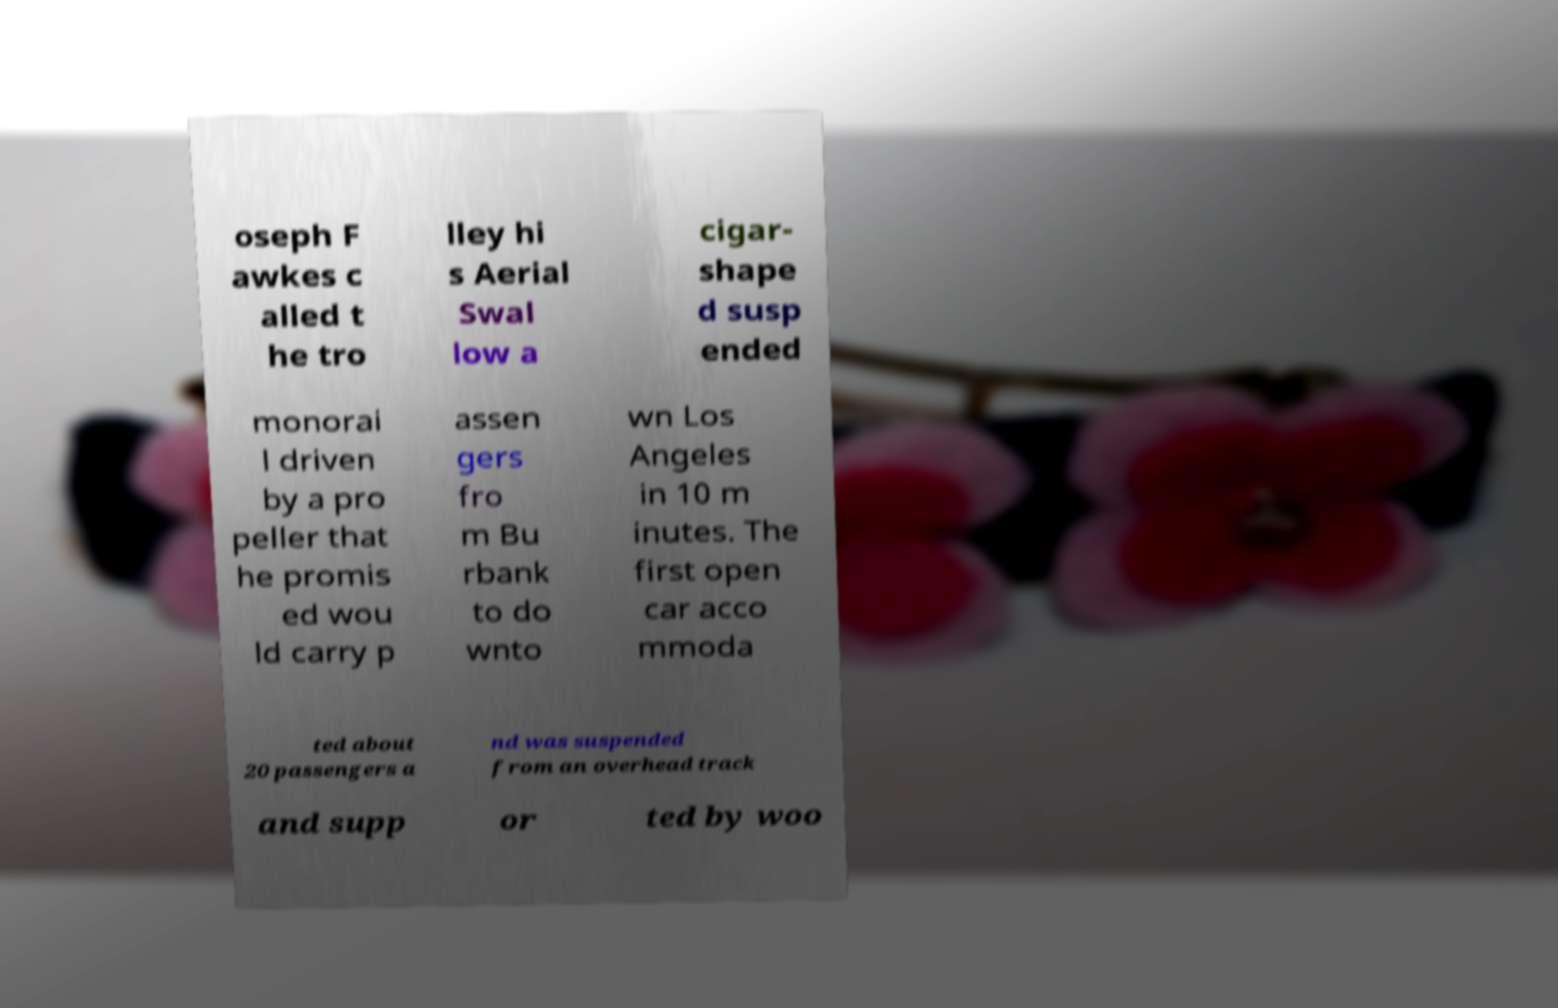Please read and relay the text visible in this image. What does it say? oseph F awkes c alled t he tro lley hi s Aerial Swal low a cigar- shape d susp ended monorai l driven by a pro peller that he promis ed wou ld carry p assen gers fro m Bu rbank to do wnto wn Los Angeles in 10 m inutes. The first open car acco mmoda ted about 20 passengers a nd was suspended from an overhead track and supp or ted by woo 